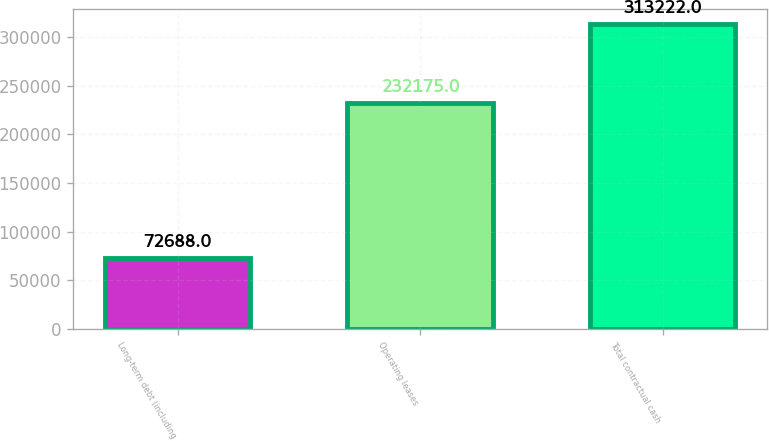<chart> <loc_0><loc_0><loc_500><loc_500><bar_chart><fcel>Long-term debt (including<fcel>Operating leases<fcel>Total contractual cash<nl><fcel>72688<fcel>232175<fcel>313222<nl></chart> 